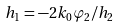<formula> <loc_0><loc_0><loc_500><loc_500>h _ { 1 } = - 2 k _ { 0 } \varphi _ { 2 } / h _ { 2 }</formula> 